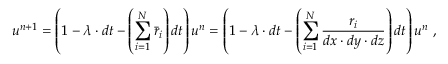<formula> <loc_0><loc_0><loc_500><loc_500>u ^ { n + 1 } = \left ( 1 - \lambda \cdot d t - \left ( \sum _ { i = 1 } ^ { N } \bar { r } _ { i } \right ) d t \right ) u ^ { n } = \left ( 1 - \lambda \cdot d t - \left ( \sum _ { i = 1 } ^ { N } \frac { r _ { i } } { d x \cdot d y \cdot d z } \right ) d t \right ) u ^ { n } \ ,</formula> 